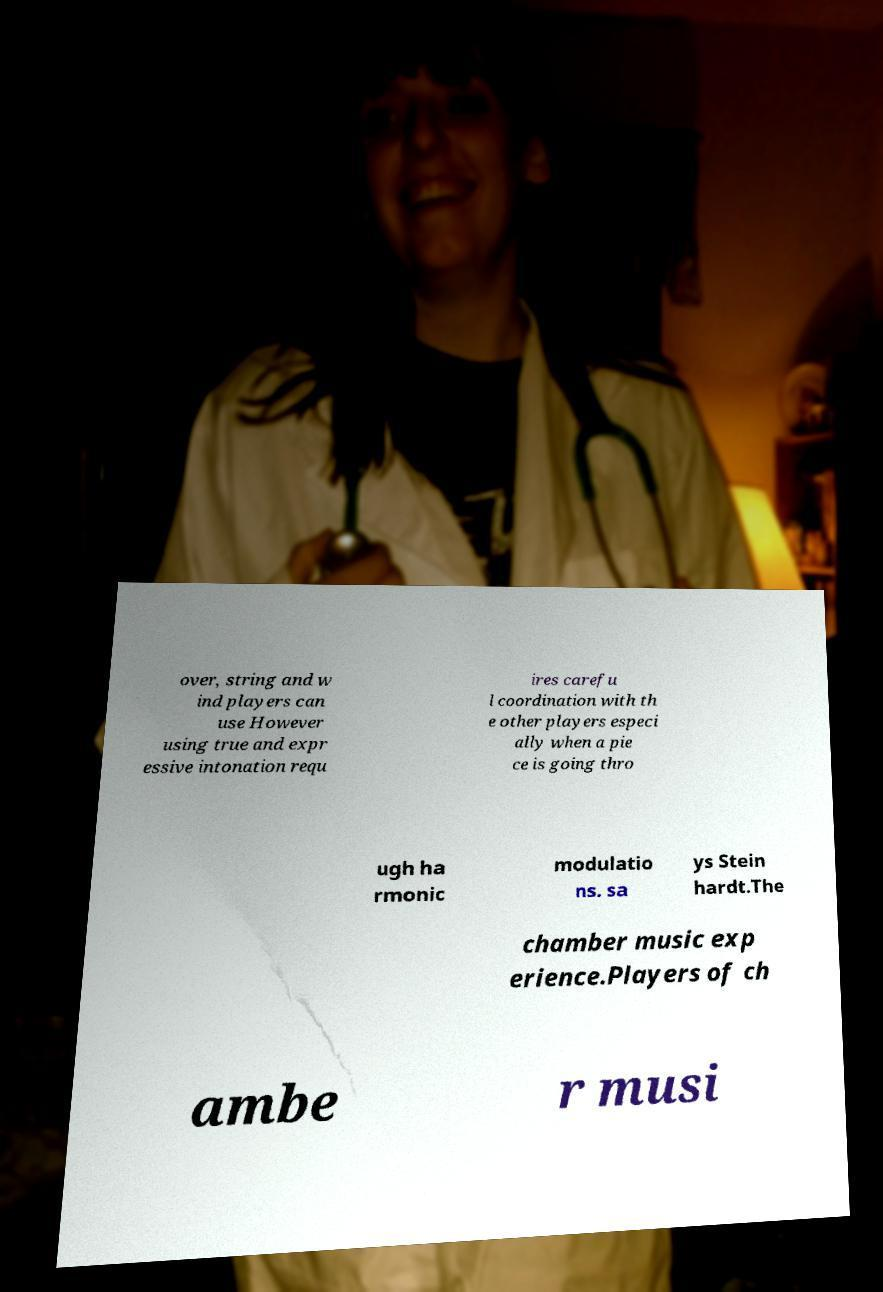Could you extract and type out the text from this image? over, string and w ind players can use However using true and expr essive intonation requ ires carefu l coordination with th e other players especi ally when a pie ce is going thro ugh ha rmonic modulatio ns. sa ys Stein hardt.The chamber music exp erience.Players of ch ambe r musi 